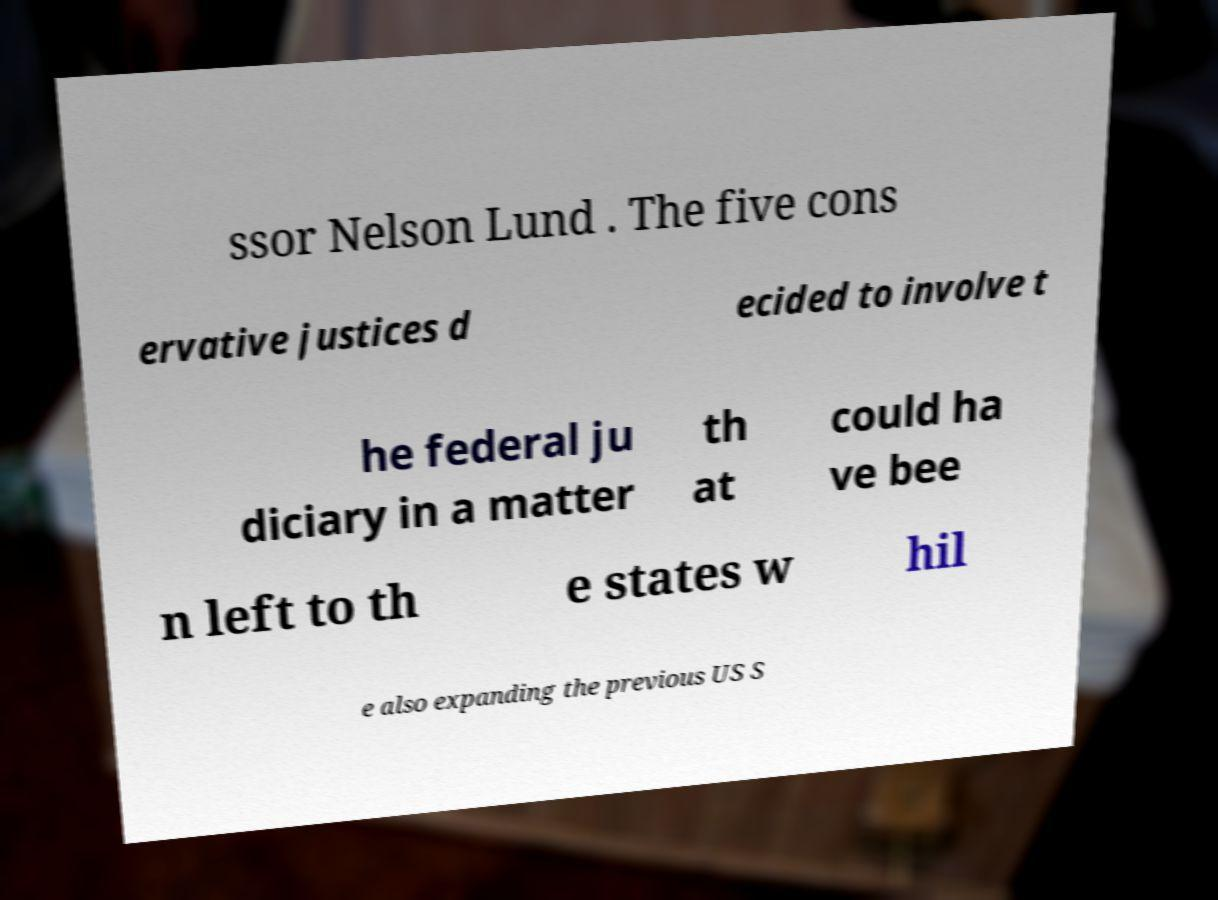What messages or text are displayed in this image? I need them in a readable, typed format. ssor Nelson Lund . The five cons ervative justices d ecided to involve t he federal ju diciary in a matter th at could ha ve bee n left to th e states w hil e also expanding the previous US S 